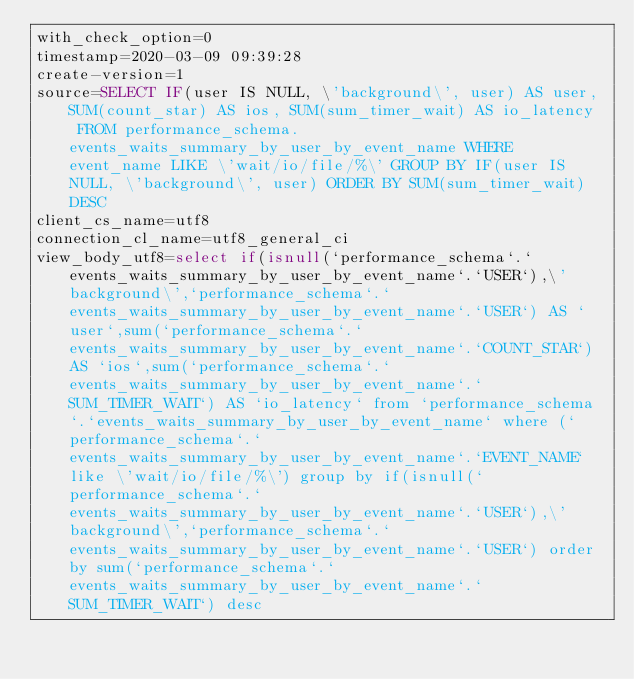<code> <loc_0><loc_0><loc_500><loc_500><_VisualBasic_>with_check_option=0
timestamp=2020-03-09 09:39:28
create-version=1
source=SELECT IF(user IS NULL, \'background\', user) AS user, SUM(count_star) AS ios, SUM(sum_timer_wait) AS io_latency  FROM performance_schema.events_waits_summary_by_user_by_event_name WHERE event_name LIKE \'wait/io/file/%\' GROUP BY IF(user IS NULL, \'background\', user) ORDER BY SUM(sum_timer_wait) DESC
client_cs_name=utf8
connection_cl_name=utf8_general_ci
view_body_utf8=select if(isnull(`performance_schema`.`events_waits_summary_by_user_by_event_name`.`USER`),\'background\',`performance_schema`.`events_waits_summary_by_user_by_event_name`.`USER`) AS `user`,sum(`performance_schema`.`events_waits_summary_by_user_by_event_name`.`COUNT_STAR`) AS `ios`,sum(`performance_schema`.`events_waits_summary_by_user_by_event_name`.`SUM_TIMER_WAIT`) AS `io_latency` from `performance_schema`.`events_waits_summary_by_user_by_event_name` where (`performance_schema`.`events_waits_summary_by_user_by_event_name`.`EVENT_NAME` like \'wait/io/file/%\') group by if(isnull(`performance_schema`.`events_waits_summary_by_user_by_event_name`.`USER`),\'background\',`performance_schema`.`events_waits_summary_by_user_by_event_name`.`USER`) order by sum(`performance_schema`.`events_waits_summary_by_user_by_event_name`.`SUM_TIMER_WAIT`) desc
</code> 